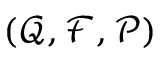<formula> <loc_0><loc_0><loc_500><loc_500>( \mathcal { Q } , \mathcal { F } , \mathcal { P } )</formula> 